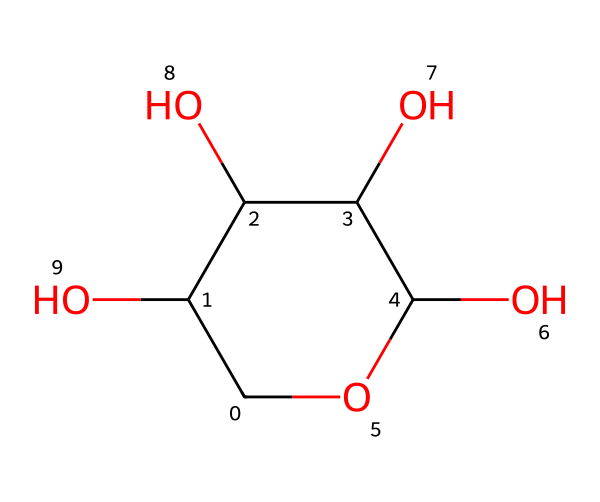What is the molecular formula of ribose? By analyzing the SMILES representation, we can identify that ribose comprises 5 carbon atoms, 10 hydrogen atoms, and 5 oxygen atoms. This gives us the formula C5H10O5.
Answer: C5H10O5 How many hydroxyl groups are present in ribose? The structure shows that there are four hydroxyl (–OH) groups, which can be identified by counting the –OH notations in the SMILES representation.
Answer: four What type of carbohydrate is ribose classified as? Ribose is a monosaccharide, which is determined by its single sugar unit structure indicated by the presence of five carbons and multiple hydroxyl groups.
Answer: monosaccharide How does ribose relate to genetic information? Ribose is a key component of ribonucleic acid (RNA), which is crucial for encoding genetic information, as it forms the backbone of RNA strands.
Answer: RNA What kind of bond connects the carbon atoms in ribose? The carbon atoms in ribose are connected by single covalent bonds, as indicated by the absence of any double or triple bond notations in the chemical structure.
Answer: single covalent bonds Which carbon atom in ribose is important for forming the RNA backbone? The first carbon (C1) is linked to the nitrogenous base and forms the glycosidic bond with it, thus playing a vital role in forming the RNA backbone.
Answer: first carbon What part of ribose provides its solubility in water? The hydroxyl groups (–OH) make ribose hydrophilic, which increases its solubility in water due to their ability to form hydrogen bonds with water molecules.
Answer: hydroxyl groups 